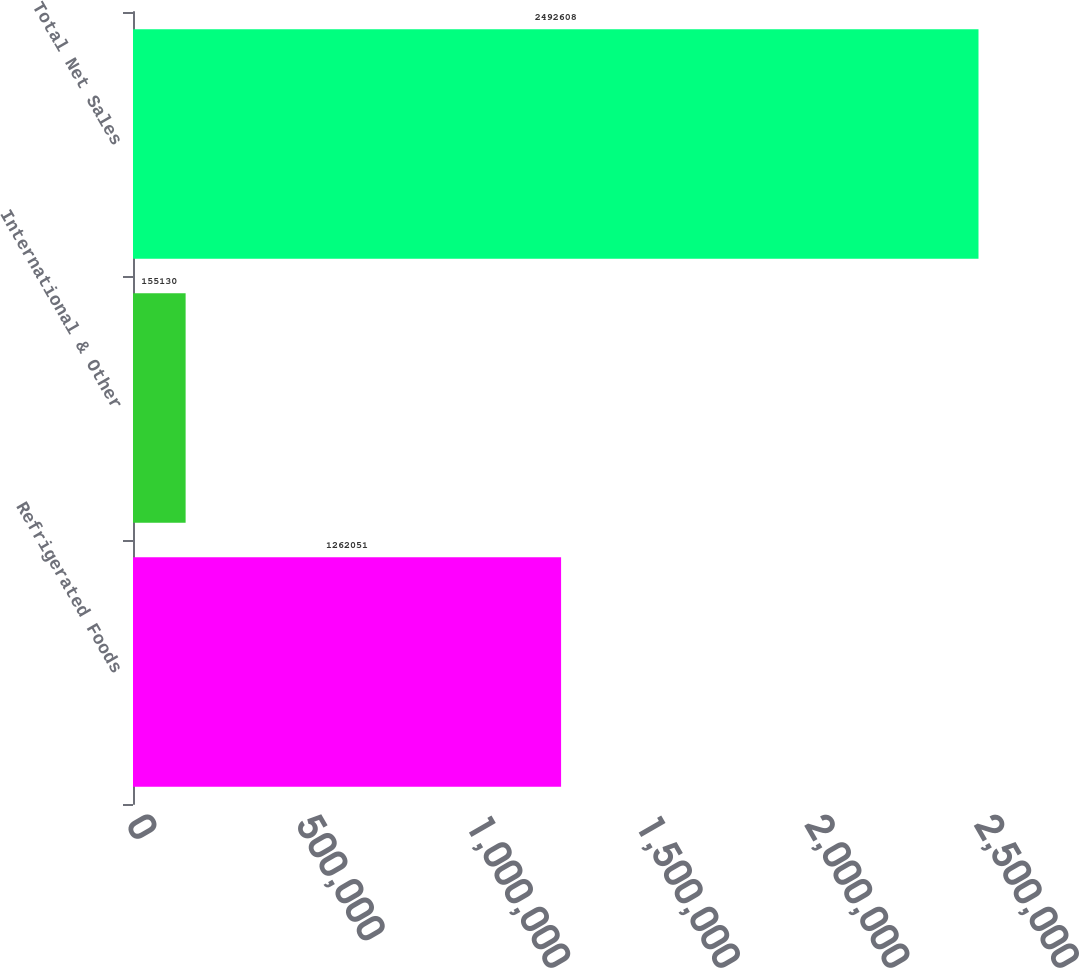<chart> <loc_0><loc_0><loc_500><loc_500><bar_chart><fcel>Refrigerated Foods<fcel>International & Other<fcel>Total Net Sales<nl><fcel>1.26205e+06<fcel>155130<fcel>2.49261e+06<nl></chart> 